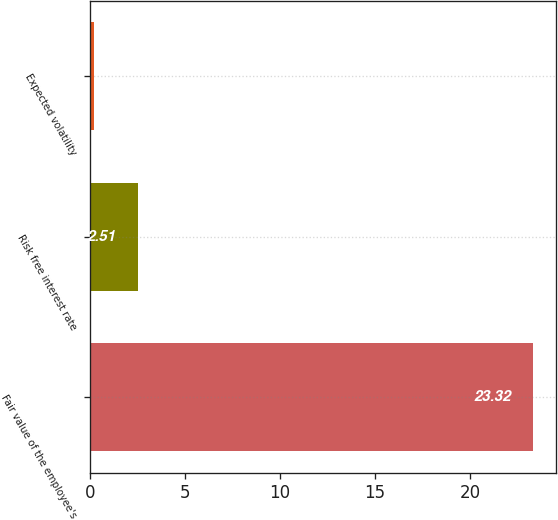Convert chart to OTSL. <chart><loc_0><loc_0><loc_500><loc_500><bar_chart><fcel>Fair value of the employee's<fcel>Risk free interest rate<fcel>Expected volatility<nl><fcel>23.32<fcel>2.51<fcel>0.2<nl></chart> 